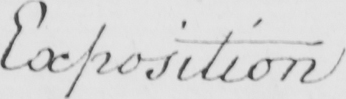Can you tell me what this handwritten text says? Exposition 